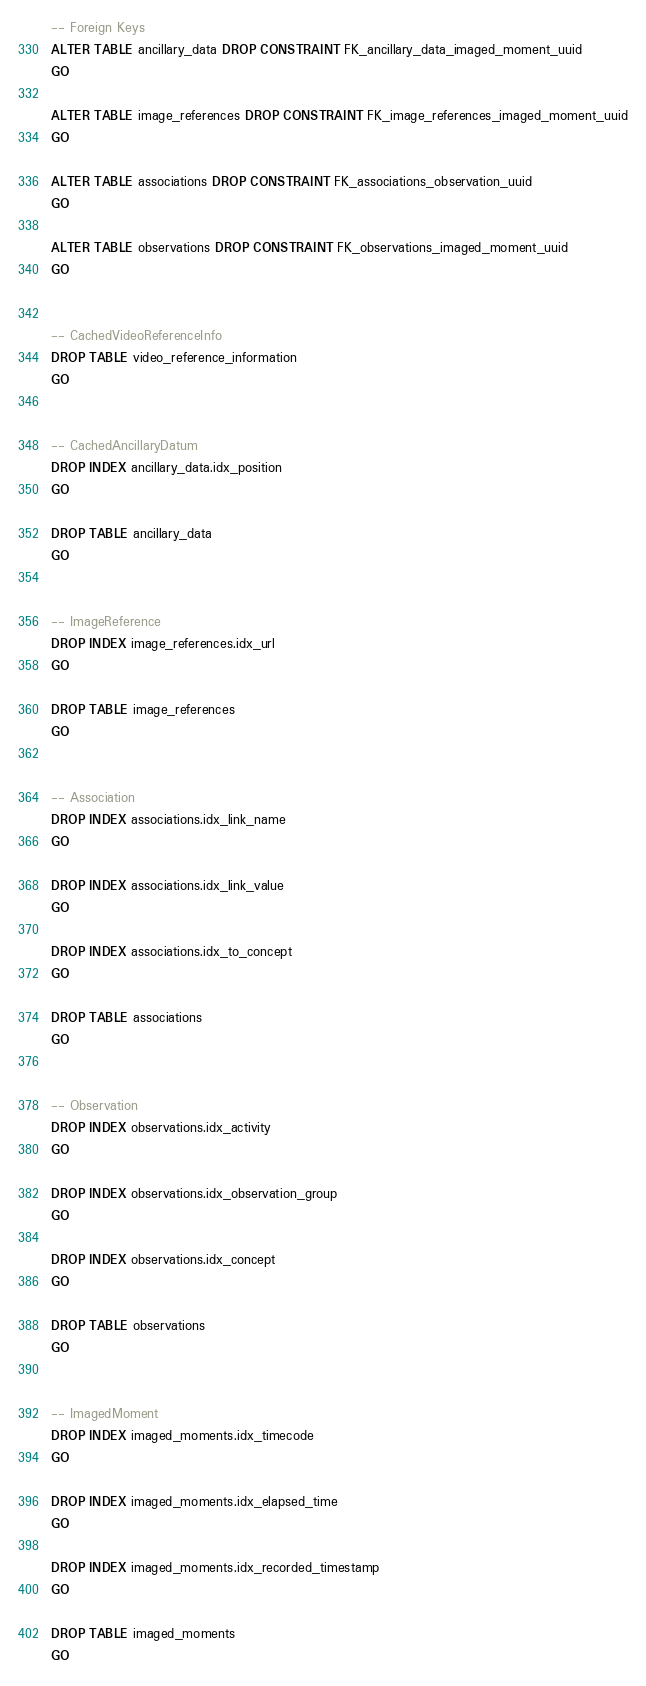Convert code to text. <code><loc_0><loc_0><loc_500><loc_500><_SQL_>-- Foreign Keys
ALTER TABLE ancillary_data DROP CONSTRAINT FK_ancillary_data_imaged_moment_uuid
GO

ALTER TABLE image_references DROP CONSTRAINT FK_image_references_imaged_moment_uuid
GO

ALTER TABLE associations DROP CONSTRAINT FK_associations_observation_uuid
GO

ALTER TABLE observations DROP CONSTRAINT FK_observations_imaged_moment_uuid
GO


-- CachedVideoReferenceInfo
DROP TABLE video_reference_information
GO


-- CachedAncillaryDatum
DROP INDEX ancillary_data.idx_position
GO

DROP TABLE ancillary_data
GO


-- ImageReference
DROP INDEX image_references.idx_url
GO

DROP TABLE image_references
GO


-- Association
DROP INDEX associations.idx_link_name
GO

DROP INDEX associations.idx_link_value
GO

DROP INDEX associations.idx_to_concept
GO

DROP TABLE associations
GO


-- Observation
DROP INDEX observations.idx_activity
GO

DROP INDEX observations.idx_observation_group
GO

DROP INDEX observations.idx_concept
GO

DROP TABLE observations
GO


-- ImagedMoment
DROP INDEX imaged_moments.idx_timecode
GO

DROP INDEX imaged_moments.idx_elapsed_time
GO

DROP INDEX imaged_moments.idx_recorded_timestamp
GO

DROP TABLE imaged_moments
GO
</code> 